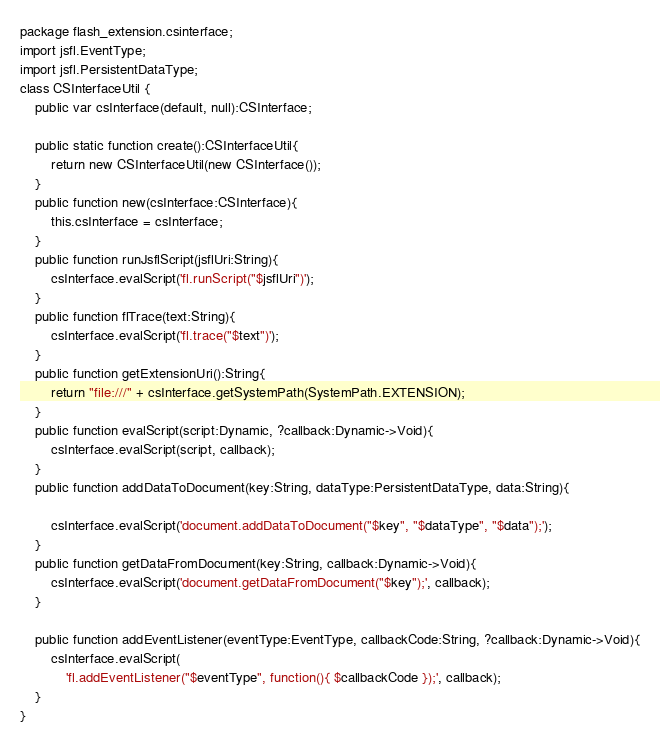<code> <loc_0><loc_0><loc_500><loc_500><_Haxe_>package flash_extension.csinterface;
import jsfl.EventType;
import jsfl.PersistentDataType;
class CSInterfaceUtil {
	public var csInterface(default, null):CSInterface;

	public static function create():CSInterfaceUtil{
		return new CSInterfaceUtil(new CSInterface());
	}
	public function new(csInterface:CSInterface){
		this.csInterface = csInterface;
	}
	public function runJsflScript(jsflUri:String){
		csInterface.evalScript('fl.runScript("$jsflUri")');
	}
	public function flTrace(text:String){
		csInterface.evalScript('fl.trace("$text")');
	}
	public function getExtensionUri():String{
		return "file:///" + csInterface.getSystemPath(SystemPath.EXTENSION);
	}
	public function evalScript(script:Dynamic, ?callback:Dynamic->Void){
		csInterface.evalScript(script, callback);
	}
	public function addDataToDocument(key:String, dataType:PersistentDataType, data:String){

		csInterface.evalScript('document.addDataToDocument("$key", "$dataType", "$data");');
	}
	public function getDataFromDocument(key:String, callback:Dynamic->Void){
		csInterface.evalScript('document.getDataFromDocument("$key");', callback);
	}

	public function addEventListener(eventType:EventType, callbackCode:String, ?callback:Dynamic->Void){
		csInterface.evalScript(
			'fl.addEventListener("$eventType", function(){ $callbackCode });', callback);
	}
}
</code> 